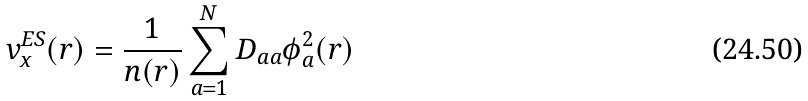<formula> <loc_0><loc_0><loc_500><loc_500>v _ { \text {x} } ^ { \text {ES} } ( { r } ) = \frac { 1 } { n ( { r } ) } \sum _ { a = 1 } ^ { N } D _ { a a } \phi _ { a } ^ { 2 } ( { r } )</formula> 